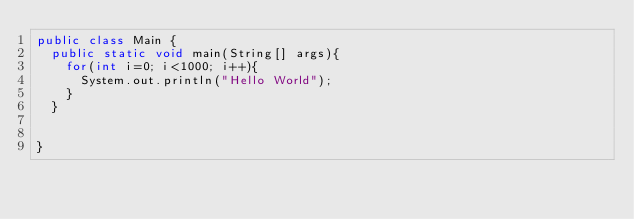Convert code to text. <code><loc_0><loc_0><loc_500><loc_500><_Java_>public class Main {
	public static void main(String[] args){
		for(int i=0; i<1000; i++){
			System.out.println("Hello World");
		}
	}
	

}</code> 